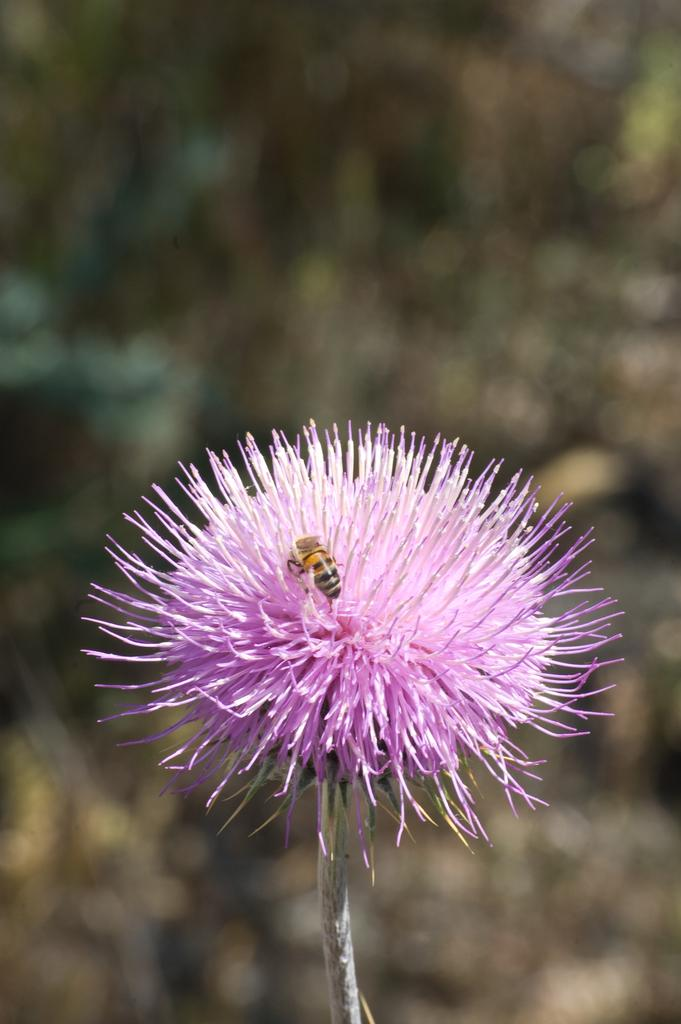What is the main subject of the image? There is a flower in the image. What color is the flower? The flower is pink in color. Is there anything interacting with the flower? Yes, there is a honey bee on the flower. How would you describe the background of the image? The background of the image is blurry. What type of liquid can be seen dripping from the fork in the image? There is no fork present in the image, so it is not possible to determine if any liquid is dripping from it. 